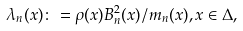Convert formula to latex. <formula><loc_0><loc_0><loc_500><loc_500>\lambda _ { n } ( x ) \colon = \rho ( x ) B _ { n } ^ { 2 } ( x ) / m _ { n } ( x ) , x \in \Delta ,</formula> 